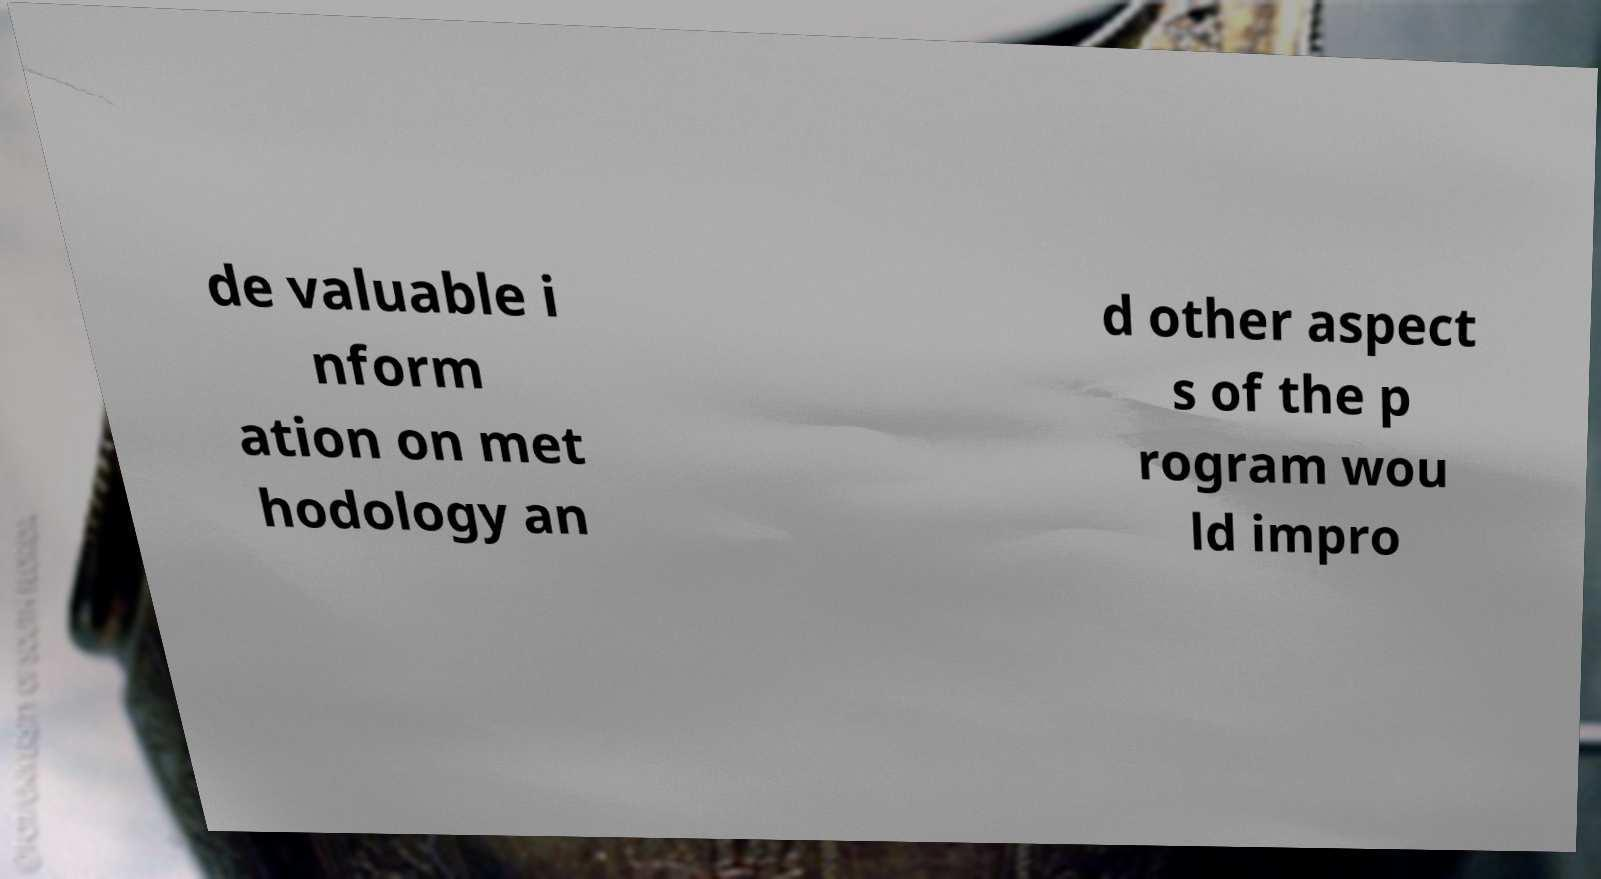What messages or text are displayed in this image? I need them in a readable, typed format. de valuable i nform ation on met hodology an d other aspect s of the p rogram wou ld impro 